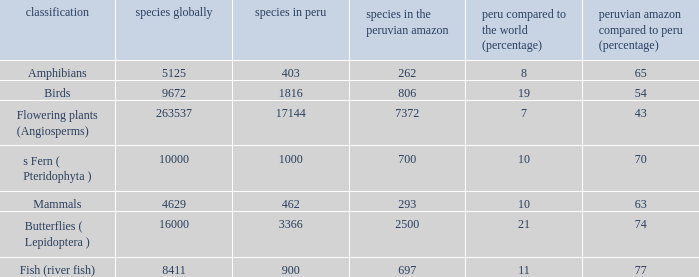What's the minimum species in the peruvian amazon with species in peru of 1000 700.0. 